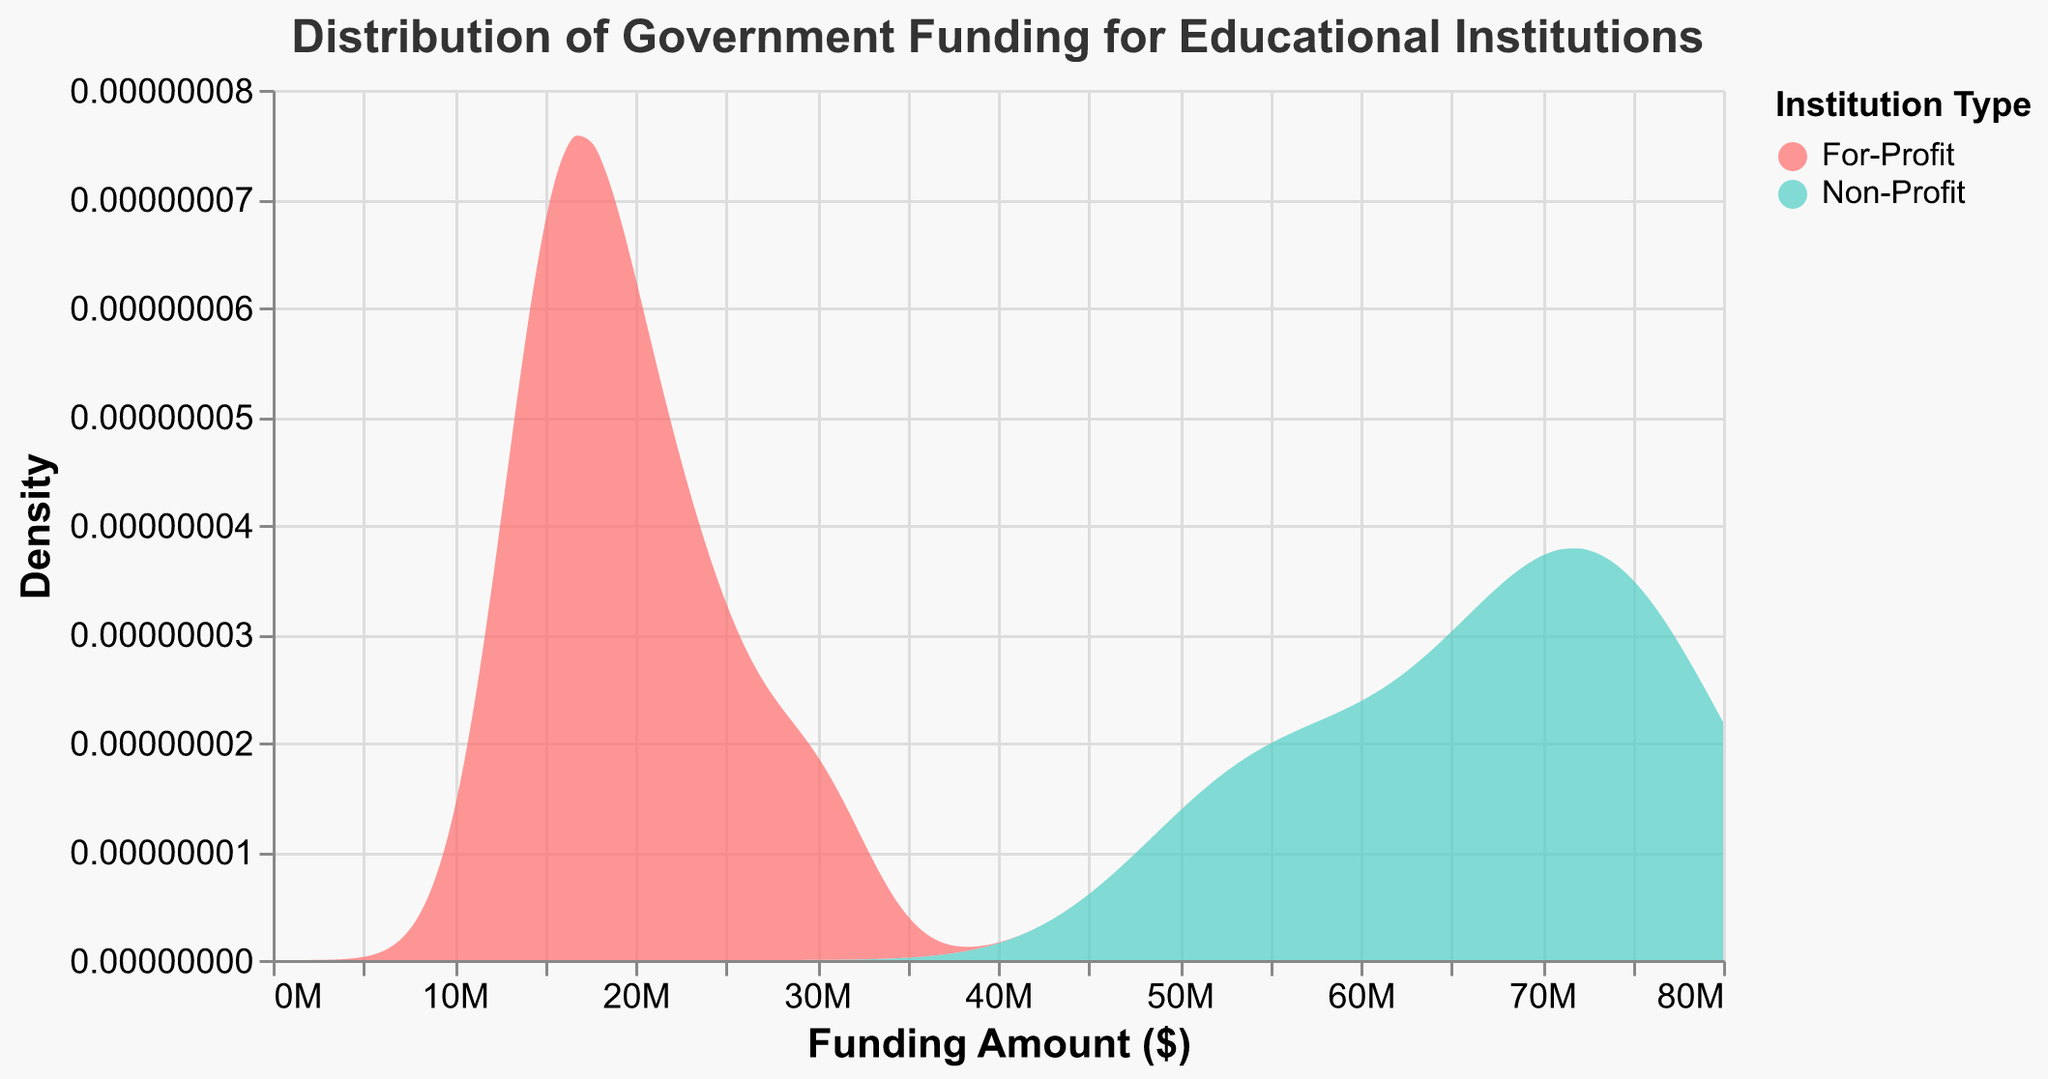What is the title of the density plot? The title can be found at the top of the plot, indicating what the figure represents.
Answer: Distribution of Government Funding for Educational Institutions What is represented on the x-axis? The x-axis label provides information about the data values plotted along this axis.
Answer: Funding Amount ($) What does the y-axis signify? The y-axis label indicates the measure that is used to plot the density on the graph.
Answer: Density What colors represent the different institution types? The legend of the plot uses different colors to differentiate between For-Profit and Non-Profit institutions.
Answer: For-Profit is red, Non-Profit is teal Which type of institution receives more government funding on average? By observing the density curves, we determine which type typically has higher funding values. The higher peak and density range of the Non-Profit institutions indicate they receive more funding on average.
Answer: Non-Profit institutions What is the maximum funding amount shown on the x-axis? We look at the highest value on the x-axis to find the maximum funding amount displayed.
Answer: 80 million dollars At what approximate funding amount does the density peak for For-Profit institutions? By observing the highest point on the For-Profit density curve, we approximate the funding amount.
Answer: Around 20 million dollars How do the funding distributions differ between For-Profit and Non-Profit institutions? By comparing the shapes and positions of the two density curves, we can infer how the funding distributions differ. Non-Profit institutions have a wider range and higher peaks at larger funding amounts compared to For-Profit institutions.
Answer: Non-Profits have higher and wider funding distributions What can be inferred about the disparity in government funding between For-Profit and Non-Profit institutions? Observing the peaks and spread of the density curves for each type of institution, we infer that Non-Profits tend to receive significantly higher government funding compared to For-Profit institutions.
Answer: Non-Profits receive significantly more funding At what approximate funding amount does the density peak for Non-Profit institutions? By observing the highest point on the Non-Profit density curve, we approximate the funding amount.
Answer: Around 70 million dollars 